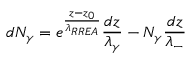Convert formula to latex. <formula><loc_0><loc_0><loc_500><loc_500>d N _ { \gamma } = e ^ { \frac { z - z _ { 0 } } { \lambda _ { R R E A } } } \frac { d z } { \lambda _ { \gamma } } - N _ { \gamma } \frac { d z } { \lambda _ { - } }</formula> 